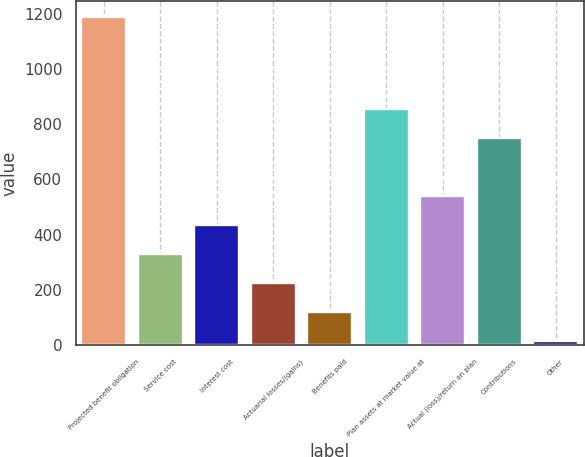<chart> <loc_0><loc_0><loc_500><loc_500><bar_chart><fcel>Projected benefit obligation<fcel>Service cost<fcel>Interest cost<fcel>Actuarial losses/(gains)<fcel>Benefits paid<fcel>Plan assets at market value at<fcel>Actual (loss)/return on plan<fcel>Contributions<fcel>Other<nl><fcel>1186.8<fcel>328.7<fcel>433.6<fcel>223.8<fcel>118.9<fcel>853.2<fcel>538.5<fcel>748.3<fcel>14<nl></chart> 